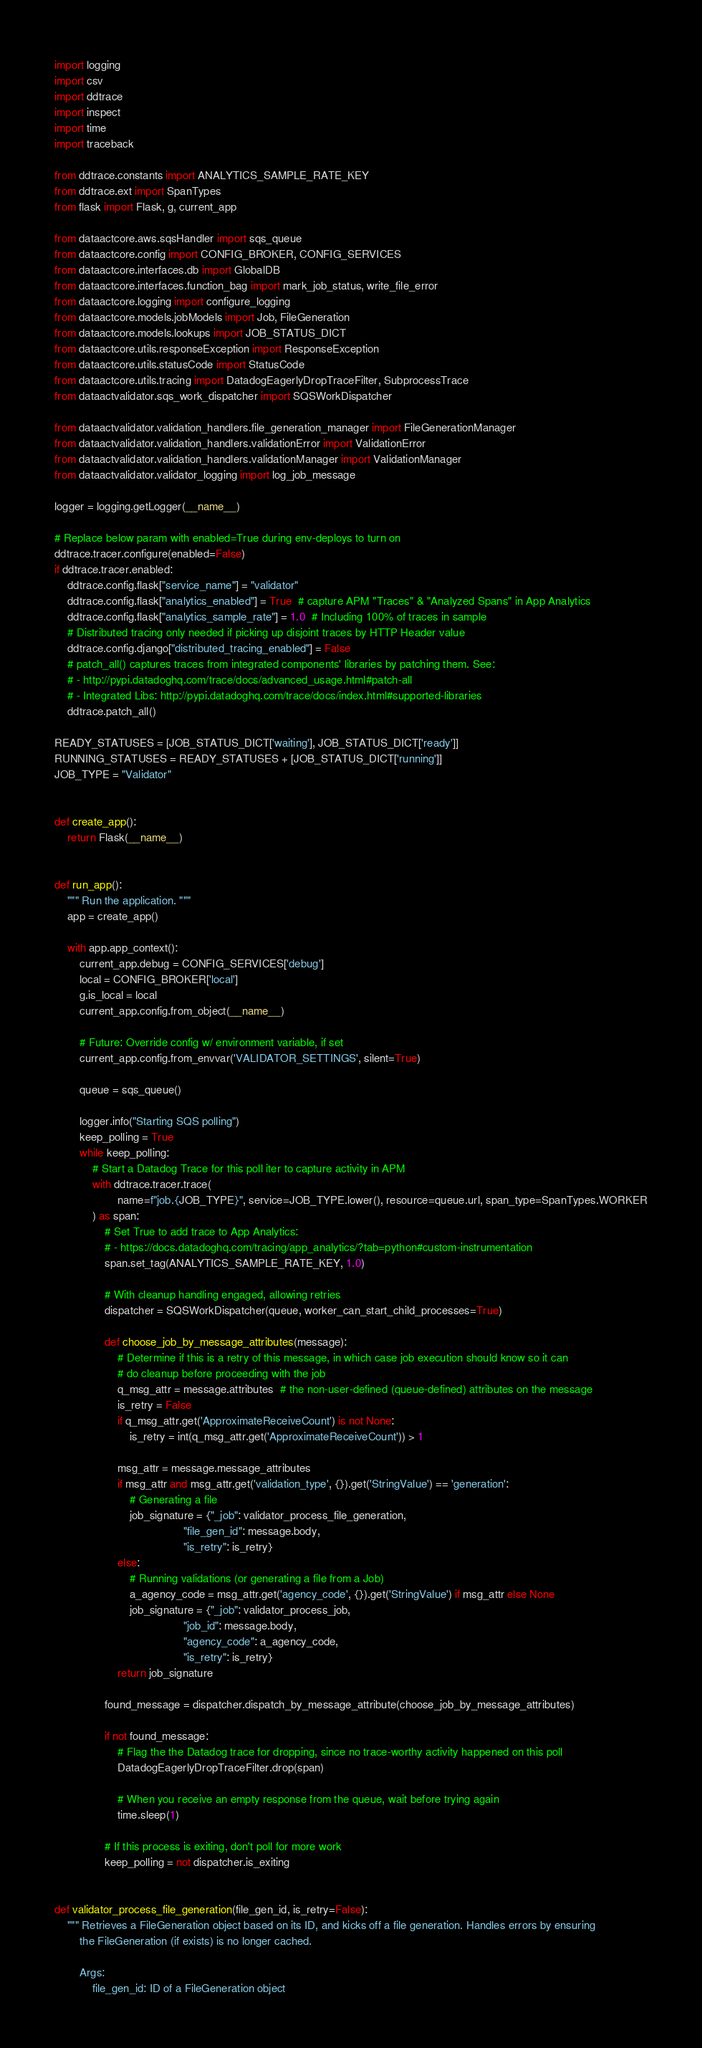<code> <loc_0><loc_0><loc_500><loc_500><_Python_>import logging
import csv
import ddtrace
import inspect
import time
import traceback

from ddtrace.constants import ANALYTICS_SAMPLE_RATE_KEY
from ddtrace.ext import SpanTypes
from flask import Flask, g, current_app

from dataactcore.aws.sqsHandler import sqs_queue
from dataactcore.config import CONFIG_BROKER, CONFIG_SERVICES
from dataactcore.interfaces.db import GlobalDB
from dataactcore.interfaces.function_bag import mark_job_status, write_file_error
from dataactcore.logging import configure_logging
from dataactcore.models.jobModels import Job, FileGeneration
from dataactcore.models.lookups import JOB_STATUS_DICT
from dataactcore.utils.responseException import ResponseException
from dataactcore.utils.statusCode import StatusCode
from dataactcore.utils.tracing import DatadogEagerlyDropTraceFilter, SubprocessTrace
from dataactvalidator.sqs_work_dispatcher import SQSWorkDispatcher

from dataactvalidator.validation_handlers.file_generation_manager import FileGenerationManager
from dataactvalidator.validation_handlers.validationError import ValidationError
from dataactvalidator.validation_handlers.validationManager import ValidationManager
from dataactvalidator.validator_logging import log_job_message

logger = logging.getLogger(__name__)

# Replace below param with enabled=True during env-deploys to turn on
ddtrace.tracer.configure(enabled=False)
if ddtrace.tracer.enabled:
    ddtrace.config.flask["service_name"] = "validator"
    ddtrace.config.flask["analytics_enabled"] = True  # capture APM "Traces" & "Analyzed Spans" in App Analytics
    ddtrace.config.flask["analytics_sample_rate"] = 1.0  # Including 100% of traces in sample
    # Distributed tracing only needed if picking up disjoint traces by HTTP Header value
    ddtrace.config.django["distributed_tracing_enabled"] = False
    # patch_all() captures traces from integrated components' libraries by patching them. See:
    # - http://pypi.datadoghq.com/trace/docs/advanced_usage.html#patch-all
    # - Integrated Libs: http://pypi.datadoghq.com/trace/docs/index.html#supported-libraries
    ddtrace.patch_all()

READY_STATUSES = [JOB_STATUS_DICT['waiting'], JOB_STATUS_DICT['ready']]
RUNNING_STATUSES = READY_STATUSES + [JOB_STATUS_DICT['running']]
JOB_TYPE = "Validator"


def create_app():
    return Flask(__name__)


def run_app():
    """ Run the application. """
    app = create_app()

    with app.app_context():
        current_app.debug = CONFIG_SERVICES['debug']
        local = CONFIG_BROKER['local']
        g.is_local = local
        current_app.config.from_object(__name__)

        # Future: Override config w/ environment variable, if set
        current_app.config.from_envvar('VALIDATOR_SETTINGS', silent=True)

        queue = sqs_queue()

        logger.info("Starting SQS polling")
        keep_polling = True
        while keep_polling:
            # Start a Datadog Trace for this poll iter to capture activity in APM
            with ddtrace.tracer.trace(
                    name=f"job.{JOB_TYPE}", service=JOB_TYPE.lower(), resource=queue.url, span_type=SpanTypes.WORKER
            ) as span:
                # Set True to add trace to App Analytics:
                # - https://docs.datadoghq.com/tracing/app_analytics/?tab=python#custom-instrumentation
                span.set_tag(ANALYTICS_SAMPLE_RATE_KEY, 1.0)

                # With cleanup handling engaged, allowing retries
                dispatcher = SQSWorkDispatcher(queue, worker_can_start_child_processes=True)

                def choose_job_by_message_attributes(message):
                    # Determine if this is a retry of this message, in which case job execution should know so it can
                    # do cleanup before proceeding with the job
                    q_msg_attr = message.attributes  # the non-user-defined (queue-defined) attributes on the message
                    is_retry = False
                    if q_msg_attr.get('ApproximateReceiveCount') is not None:
                        is_retry = int(q_msg_attr.get('ApproximateReceiveCount')) > 1

                    msg_attr = message.message_attributes
                    if msg_attr and msg_attr.get('validation_type', {}).get('StringValue') == 'generation':
                        # Generating a file
                        job_signature = {"_job": validator_process_file_generation,
                                         "file_gen_id": message.body,
                                         "is_retry": is_retry}
                    else:
                        # Running validations (or generating a file from a Job)
                        a_agency_code = msg_attr.get('agency_code', {}).get('StringValue') if msg_attr else None
                        job_signature = {"_job": validator_process_job,
                                         "job_id": message.body,
                                         "agency_code": a_agency_code,
                                         "is_retry": is_retry}
                    return job_signature

                found_message = dispatcher.dispatch_by_message_attribute(choose_job_by_message_attributes)

                if not found_message:
                    # Flag the the Datadog trace for dropping, since no trace-worthy activity happened on this poll
                    DatadogEagerlyDropTraceFilter.drop(span)

                    # When you receive an empty response from the queue, wait before trying again
                    time.sleep(1)

                # If this process is exiting, don't poll for more work
                keep_polling = not dispatcher.is_exiting


def validator_process_file_generation(file_gen_id, is_retry=False):
    """ Retrieves a FileGeneration object based on its ID, and kicks off a file generation. Handles errors by ensuring
        the FileGeneration (if exists) is no longer cached.

        Args:
            file_gen_id: ID of a FileGeneration object</code> 